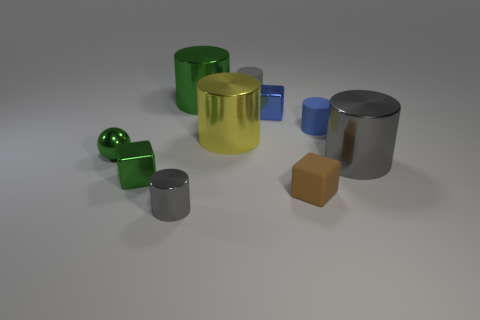Subtract all small metal blocks. How many blocks are left? 1 Subtract all green cylinders. How many cylinders are left? 5 Subtract all yellow cubes. How many gray cylinders are left? 3 Subtract 4 cylinders. How many cylinders are left? 2 Add 6 brown blocks. How many brown blocks are left? 7 Add 8 green metallic cylinders. How many green metallic cylinders exist? 9 Subtract 0 red cylinders. How many objects are left? 10 Subtract all cylinders. How many objects are left? 4 Subtract all yellow balls. Subtract all gray cubes. How many balls are left? 1 Subtract all yellow metal balls. Subtract all gray objects. How many objects are left? 7 